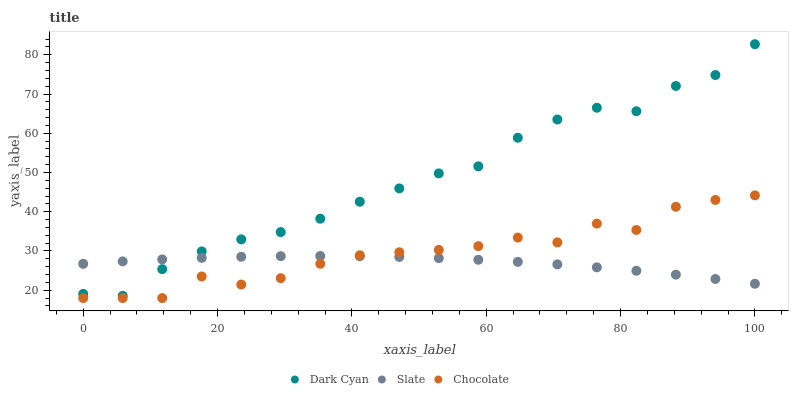Does Slate have the minimum area under the curve?
Answer yes or no. Yes. Does Dark Cyan have the maximum area under the curve?
Answer yes or no. Yes. Does Chocolate have the minimum area under the curve?
Answer yes or no. No. Does Chocolate have the maximum area under the curve?
Answer yes or no. No. Is Slate the smoothest?
Answer yes or no. Yes. Is Chocolate the roughest?
Answer yes or no. Yes. Is Chocolate the smoothest?
Answer yes or no. No. Is Slate the roughest?
Answer yes or no. No. Does Chocolate have the lowest value?
Answer yes or no. Yes. Does Slate have the lowest value?
Answer yes or no. No. Does Dark Cyan have the highest value?
Answer yes or no. Yes. Does Chocolate have the highest value?
Answer yes or no. No. Is Chocolate less than Dark Cyan?
Answer yes or no. Yes. Is Dark Cyan greater than Chocolate?
Answer yes or no. Yes. Does Slate intersect Chocolate?
Answer yes or no. Yes. Is Slate less than Chocolate?
Answer yes or no. No. Is Slate greater than Chocolate?
Answer yes or no. No. Does Chocolate intersect Dark Cyan?
Answer yes or no. No. 